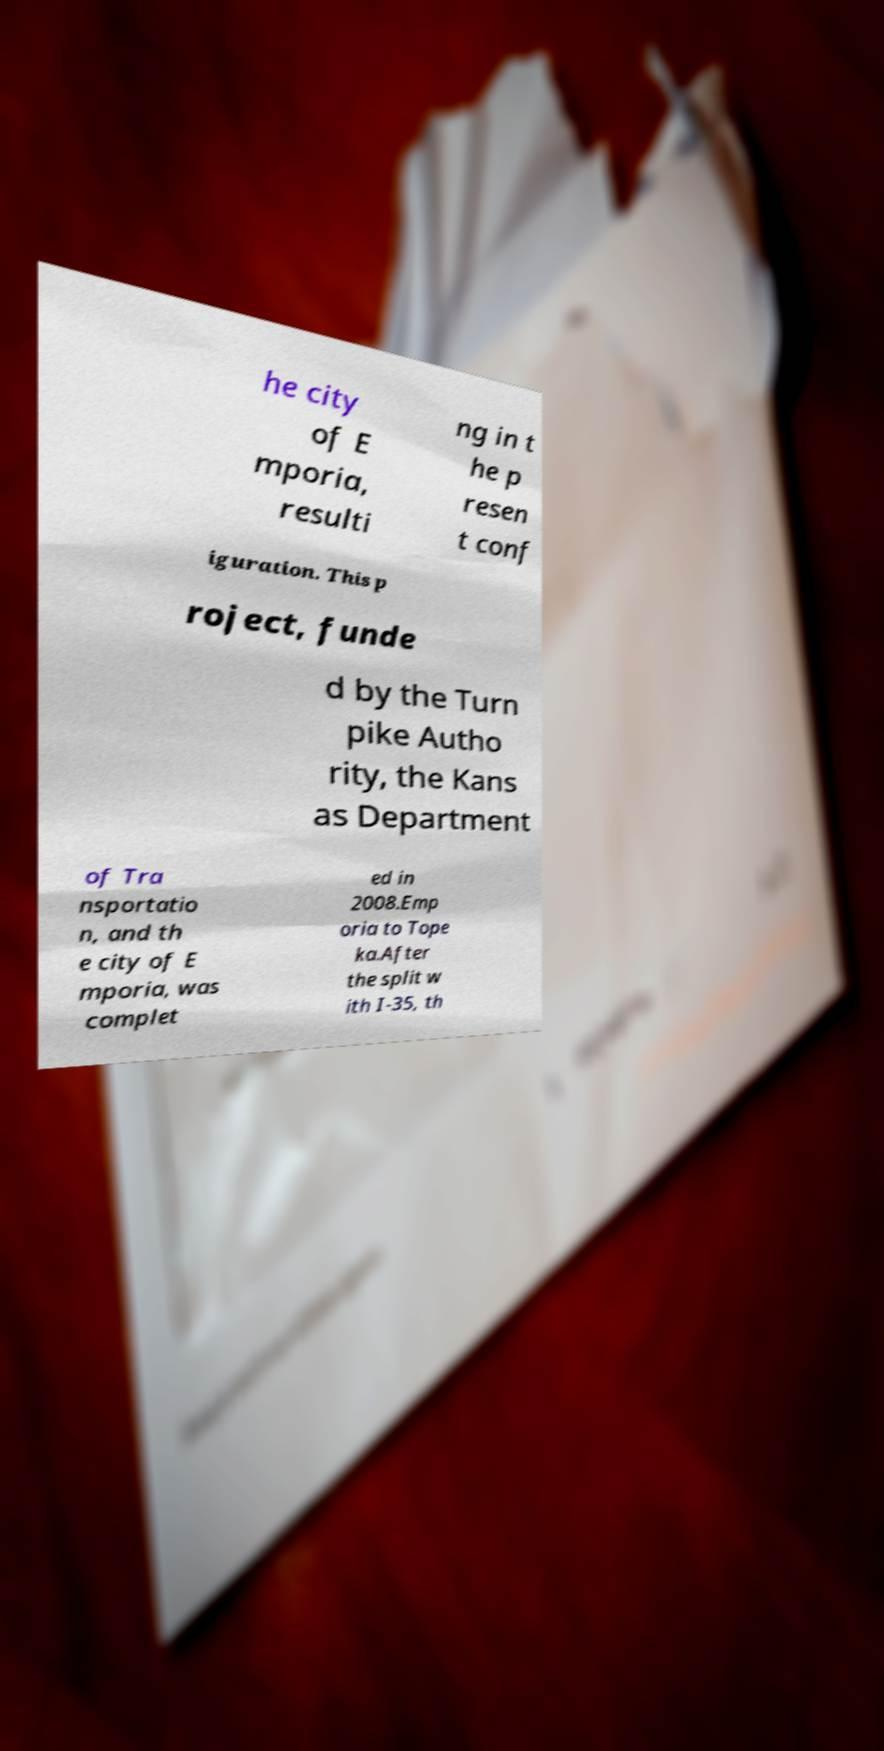Please identify and transcribe the text found in this image. he city of E mporia, resulti ng in t he p resen t conf iguration. This p roject, funde d by the Turn pike Autho rity, the Kans as Department of Tra nsportatio n, and th e city of E mporia, was complet ed in 2008.Emp oria to Tope ka.After the split w ith I-35, th 